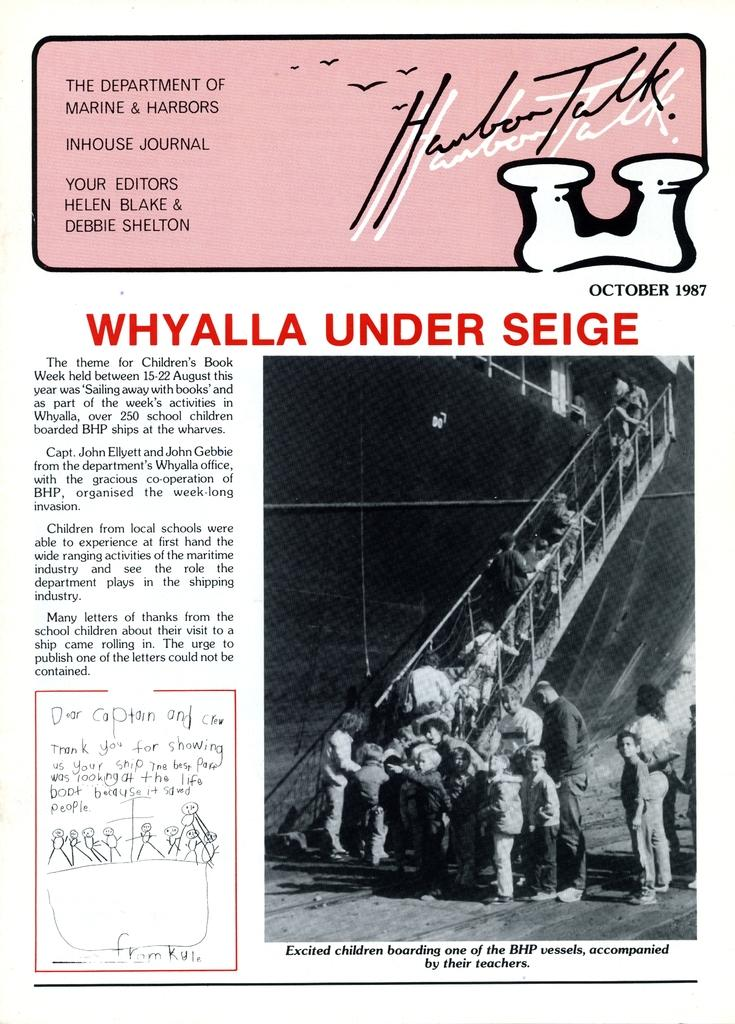<image>
Provide a brief description of the given image. a paper with the Department of Marine and Harbors on it 